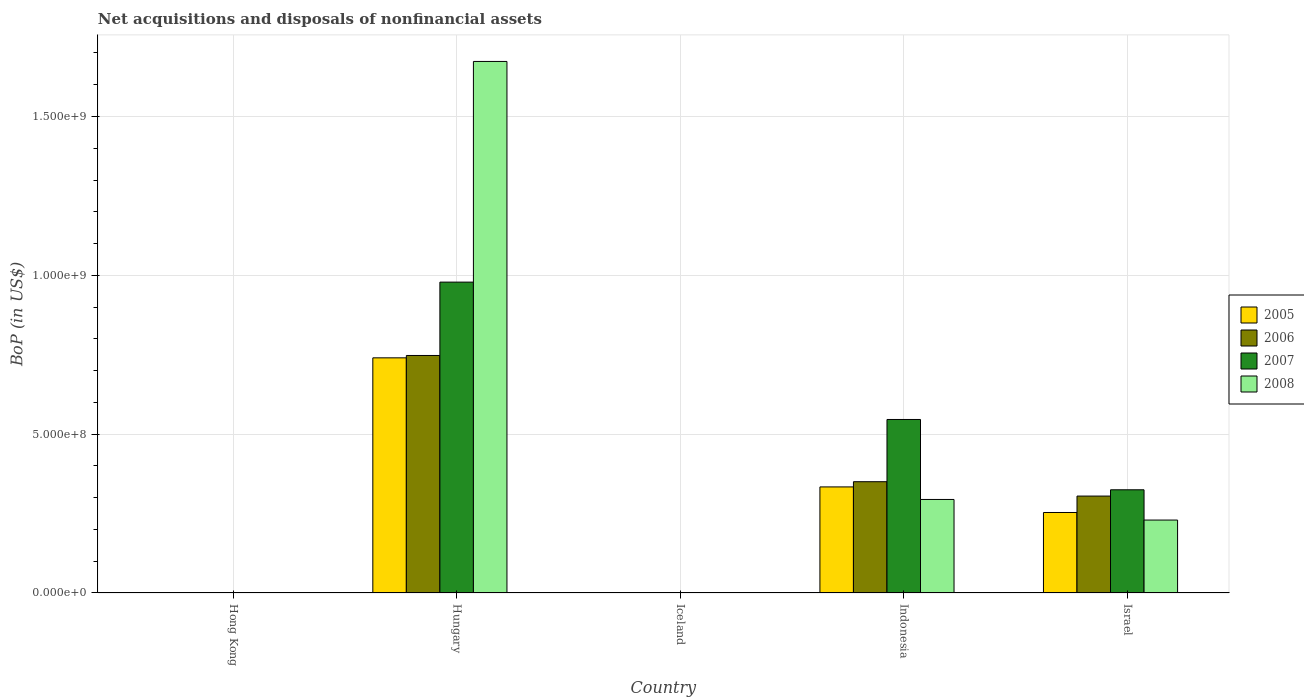How many different coloured bars are there?
Your answer should be very brief. 4. In how many cases, is the number of bars for a given country not equal to the number of legend labels?
Give a very brief answer. 2. What is the Balance of Payments in 2007 in Hong Kong?
Make the answer very short. 0. Across all countries, what is the maximum Balance of Payments in 2007?
Make the answer very short. 9.79e+08. In which country was the Balance of Payments in 2008 maximum?
Provide a succinct answer. Hungary. What is the total Balance of Payments in 2006 in the graph?
Your response must be concise. 1.40e+09. What is the difference between the Balance of Payments in 2006 in Hungary and that in Israel?
Your response must be concise. 4.43e+08. What is the difference between the Balance of Payments in 2007 in Israel and the Balance of Payments in 2006 in Hong Kong?
Provide a short and direct response. 3.25e+08. What is the average Balance of Payments in 2008 per country?
Offer a terse response. 4.39e+08. What is the difference between the Balance of Payments of/in 2008 and Balance of Payments of/in 2005 in Israel?
Make the answer very short. -2.38e+07. In how many countries, is the Balance of Payments in 2008 greater than 1200000000 US$?
Keep it short and to the point. 1. What is the ratio of the Balance of Payments in 2005 in Hungary to that in Israel?
Provide a short and direct response. 2.92. Is the difference between the Balance of Payments in 2008 in Indonesia and Israel greater than the difference between the Balance of Payments in 2005 in Indonesia and Israel?
Give a very brief answer. No. What is the difference between the highest and the second highest Balance of Payments in 2005?
Your answer should be very brief. -4.87e+08. What is the difference between the highest and the lowest Balance of Payments in 2008?
Offer a terse response. 1.67e+09. In how many countries, is the Balance of Payments in 2008 greater than the average Balance of Payments in 2008 taken over all countries?
Give a very brief answer. 1. Is it the case that in every country, the sum of the Balance of Payments in 2006 and Balance of Payments in 2008 is greater than the Balance of Payments in 2005?
Ensure brevity in your answer.  No. Are the values on the major ticks of Y-axis written in scientific E-notation?
Keep it short and to the point. Yes. Does the graph contain any zero values?
Your answer should be compact. Yes. Does the graph contain grids?
Keep it short and to the point. Yes. Where does the legend appear in the graph?
Give a very brief answer. Center right. How are the legend labels stacked?
Ensure brevity in your answer.  Vertical. What is the title of the graph?
Keep it short and to the point. Net acquisitions and disposals of nonfinancial assets. What is the label or title of the Y-axis?
Give a very brief answer. BoP (in US$). What is the BoP (in US$) of 2006 in Hong Kong?
Provide a succinct answer. 0. What is the BoP (in US$) of 2007 in Hong Kong?
Offer a terse response. 0. What is the BoP (in US$) of 2005 in Hungary?
Provide a succinct answer. 7.40e+08. What is the BoP (in US$) of 2006 in Hungary?
Offer a very short reply. 7.48e+08. What is the BoP (in US$) in 2007 in Hungary?
Give a very brief answer. 9.79e+08. What is the BoP (in US$) in 2008 in Hungary?
Your response must be concise. 1.67e+09. What is the BoP (in US$) in 2005 in Iceland?
Offer a very short reply. 0. What is the BoP (in US$) of 2008 in Iceland?
Give a very brief answer. 0. What is the BoP (in US$) in 2005 in Indonesia?
Ensure brevity in your answer.  3.34e+08. What is the BoP (in US$) in 2006 in Indonesia?
Ensure brevity in your answer.  3.50e+08. What is the BoP (in US$) of 2007 in Indonesia?
Make the answer very short. 5.46e+08. What is the BoP (in US$) of 2008 in Indonesia?
Make the answer very short. 2.94e+08. What is the BoP (in US$) in 2005 in Israel?
Offer a terse response. 2.53e+08. What is the BoP (in US$) in 2006 in Israel?
Offer a very short reply. 3.05e+08. What is the BoP (in US$) in 2007 in Israel?
Ensure brevity in your answer.  3.25e+08. What is the BoP (in US$) in 2008 in Israel?
Offer a terse response. 2.30e+08. Across all countries, what is the maximum BoP (in US$) in 2005?
Your answer should be compact. 7.40e+08. Across all countries, what is the maximum BoP (in US$) in 2006?
Ensure brevity in your answer.  7.48e+08. Across all countries, what is the maximum BoP (in US$) of 2007?
Give a very brief answer. 9.79e+08. Across all countries, what is the maximum BoP (in US$) in 2008?
Your answer should be very brief. 1.67e+09. Across all countries, what is the minimum BoP (in US$) in 2005?
Your answer should be very brief. 0. Across all countries, what is the minimum BoP (in US$) in 2006?
Provide a succinct answer. 0. Across all countries, what is the minimum BoP (in US$) of 2007?
Keep it short and to the point. 0. What is the total BoP (in US$) of 2005 in the graph?
Give a very brief answer. 1.33e+09. What is the total BoP (in US$) of 2006 in the graph?
Offer a terse response. 1.40e+09. What is the total BoP (in US$) of 2007 in the graph?
Your answer should be very brief. 1.85e+09. What is the total BoP (in US$) in 2008 in the graph?
Offer a very short reply. 2.20e+09. What is the difference between the BoP (in US$) of 2005 in Hungary and that in Indonesia?
Make the answer very short. 4.06e+08. What is the difference between the BoP (in US$) in 2006 in Hungary and that in Indonesia?
Your response must be concise. 3.97e+08. What is the difference between the BoP (in US$) in 2007 in Hungary and that in Indonesia?
Offer a terse response. 4.32e+08. What is the difference between the BoP (in US$) in 2008 in Hungary and that in Indonesia?
Provide a short and direct response. 1.38e+09. What is the difference between the BoP (in US$) of 2005 in Hungary and that in Israel?
Give a very brief answer. 4.87e+08. What is the difference between the BoP (in US$) of 2006 in Hungary and that in Israel?
Offer a very short reply. 4.43e+08. What is the difference between the BoP (in US$) in 2007 in Hungary and that in Israel?
Offer a terse response. 6.54e+08. What is the difference between the BoP (in US$) of 2008 in Hungary and that in Israel?
Give a very brief answer. 1.44e+09. What is the difference between the BoP (in US$) in 2005 in Indonesia and that in Israel?
Provide a succinct answer. 8.05e+07. What is the difference between the BoP (in US$) of 2006 in Indonesia and that in Israel?
Your answer should be very brief. 4.52e+07. What is the difference between the BoP (in US$) in 2007 in Indonesia and that in Israel?
Offer a terse response. 2.21e+08. What is the difference between the BoP (in US$) of 2008 in Indonesia and that in Israel?
Keep it short and to the point. 6.49e+07. What is the difference between the BoP (in US$) of 2005 in Hungary and the BoP (in US$) of 2006 in Indonesia?
Offer a terse response. 3.90e+08. What is the difference between the BoP (in US$) of 2005 in Hungary and the BoP (in US$) of 2007 in Indonesia?
Offer a terse response. 1.94e+08. What is the difference between the BoP (in US$) of 2005 in Hungary and the BoP (in US$) of 2008 in Indonesia?
Provide a short and direct response. 4.46e+08. What is the difference between the BoP (in US$) in 2006 in Hungary and the BoP (in US$) in 2007 in Indonesia?
Your response must be concise. 2.01e+08. What is the difference between the BoP (in US$) in 2006 in Hungary and the BoP (in US$) in 2008 in Indonesia?
Offer a very short reply. 4.53e+08. What is the difference between the BoP (in US$) in 2007 in Hungary and the BoP (in US$) in 2008 in Indonesia?
Your answer should be compact. 6.84e+08. What is the difference between the BoP (in US$) of 2005 in Hungary and the BoP (in US$) of 2006 in Israel?
Give a very brief answer. 4.35e+08. What is the difference between the BoP (in US$) in 2005 in Hungary and the BoP (in US$) in 2007 in Israel?
Give a very brief answer. 4.15e+08. What is the difference between the BoP (in US$) of 2005 in Hungary and the BoP (in US$) of 2008 in Israel?
Provide a succinct answer. 5.11e+08. What is the difference between the BoP (in US$) in 2006 in Hungary and the BoP (in US$) in 2007 in Israel?
Provide a short and direct response. 4.23e+08. What is the difference between the BoP (in US$) in 2006 in Hungary and the BoP (in US$) in 2008 in Israel?
Offer a terse response. 5.18e+08. What is the difference between the BoP (in US$) of 2007 in Hungary and the BoP (in US$) of 2008 in Israel?
Offer a terse response. 7.49e+08. What is the difference between the BoP (in US$) of 2005 in Indonesia and the BoP (in US$) of 2006 in Israel?
Ensure brevity in your answer.  2.88e+07. What is the difference between the BoP (in US$) of 2005 in Indonesia and the BoP (in US$) of 2007 in Israel?
Offer a terse response. 9.02e+06. What is the difference between the BoP (in US$) of 2005 in Indonesia and the BoP (in US$) of 2008 in Israel?
Offer a very short reply. 1.04e+08. What is the difference between the BoP (in US$) in 2006 in Indonesia and the BoP (in US$) in 2007 in Israel?
Give a very brief answer. 2.54e+07. What is the difference between the BoP (in US$) of 2006 in Indonesia and the BoP (in US$) of 2008 in Israel?
Offer a terse response. 1.21e+08. What is the difference between the BoP (in US$) of 2007 in Indonesia and the BoP (in US$) of 2008 in Israel?
Offer a terse response. 3.17e+08. What is the average BoP (in US$) of 2005 per country?
Keep it short and to the point. 2.66e+08. What is the average BoP (in US$) of 2006 per country?
Your response must be concise. 2.81e+08. What is the average BoP (in US$) in 2007 per country?
Ensure brevity in your answer.  3.70e+08. What is the average BoP (in US$) in 2008 per country?
Ensure brevity in your answer.  4.39e+08. What is the difference between the BoP (in US$) of 2005 and BoP (in US$) of 2006 in Hungary?
Keep it short and to the point. -7.44e+06. What is the difference between the BoP (in US$) in 2005 and BoP (in US$) in 2007 in Hungary?
Your response must be concise. -2.38e+08. What is the difference between the BoP (in US$) of 2005 and BoP (in US$) of 2008 in Hungary?
Ensure brevity in your answer.  -9.33e+08. What is the difference between the BoP (in US$) of 2006 and BoP (in US$) of 2007 in Hungary?
Provide a succinct answer. -2.31e+08. What is the difference between the BoP (in US$) of 2006 and BoP (in US$) of 2008 in Hungary?
Provide a succinct answer. -9.26e+08. What is the difference between the BoP (in US$) in 2007 and BoP (in US$) in 2008 in Hungary?
Offer a very short reply. -6.95e+08. What is the difference between the BoP (in US$) of 2005 and BoP (in US$) of 2006 in Indonesia?
Keep it short and to the point. -1.64e+07. What is the difference between the BoP (in US$) in 2005 and BoP (in US$) in 2007 in Indonesia?
Your response must be concise. -2.12e+08. What is the difference between the BoP (in US$) of 2005 and BoP (in US$) of 2008 in Indonesia?
Give a very brief answer. 3.95e+07. What is the difference between the BoP (in US$) of 2006 and BoP (in US$) of 2007 in Indonesia?
Ensure brevity in your answer.  -1.96e+08. What is the difference between the BoP (in US$) in 2006 and BoP (in US$) in 2008 in Indonesia?
Give a very brief answer. 5.59e+07. What is the difference between the BoP (in US$) in 2007 and BoP (in US$) in 2008 in Indonesia?
Keep it short and to the point. 2.52e+08. What is the difference between the BoP (in US$) of 2005 and BoP (in US$) of 2006 in Israel?
Provide a succinct answer. -5.17e+07. What is the difference between the BoP (in US$) of 2005 and BoP (in US$) of 2007 in Israel?
Offer a very short reply. -7.15e+07. What is the difference between the BoP (in US$) in 2005 and BoP (in US$) in 2008 in Israel?
Provide a succinct answer. 2.38e+07. What is the difference between the BoP (in US$) in 2006 and BoP (in US$) in 2007 in Israel?
Make the answer very short. -1.98e+07. What is the difference between the BoP (in US$) of 2006 and BoP (in US$) of 2008 in Israel?
Make the answer very short. 7.55e+07. What is the difference between the BoP (in US$) of 2007 and BoP (in US$) of 2008 in Israel?
Keep it short and to the point. 9.53e+07. What is the ratio of the BoP (in US$) of 2005 in Hungary to that in Indonesia?
Offer a very short reply. 2.22. What is the ratio of the BoP (in US$) of 2006 in Hungary to that in Indonesia?
Offer a very short reply. 2.13. What is the ratio of the BoP (in US$) of 2007 in Hungary to that in Indonesia?
Give a very brief answer. 1.79. What is the ratio of the BoP (in US$) in 2008 in Hungary to that in Indonesia?
Make the answer very short. 5.68. What is the ratio of the BoP (in US$) in 2005 in Hungary to that in Israel?
Ensure brevity in your answer.  2.92. What is the ratio of the BoP (in US$) in 2006 in Hungary to that in Israel?
Make the answer very short. 2.45. What is the ratio of the BoP (in US$) of 2007 in Hungary to that in Israel?
Your answer should be compact. 3.01. What is the ratio of the BoP (in US$) of 2008 in Hungary to that in Israel?
Ensure brevity in your answer.  7.29. What is the ratio of the BoP (in US$) of 2005 in Indonesia to that in Israel?
Your response must be concise. 1.32. What is the ratio of the BoP (in US$) of 2006 in Indonesia to that in Israel?
Your answer should be very brief. 1.15. What is the ratio of the BoP (in US$) of 2007 in Indonesia to that in Israel?
Your response must be concise. 1.68. What is the ratio of the BoP (in US$) in 2008 in Indonesia to that in Israel?
Provide a succinct answer. 1.28. What is the difference between the highest and the second highest BoP (in US$) of 2005?
Ensure brevity in your answer.  4.06e+08. What is the difference between the highest and the second highest BoP (in US$) of 2006?
Provide a short and direct response. 3.97e+08. What is the difference between the highest and the second highest BoP (in US$) in 2007?
Ensure brevity in your answer.  4.32e+08. What is the difference between the highest and the second highest BoP (in US$) in 2008?
Your answer should be very brief. 1.38e+09. What is the difference between the highest and the lowest BoP (in US$) of 2005?
Offer a terse response. 7.40e+08. What is the difference between the highest and the lowest BoP (in US$) in 2006?
Give a very brief answer. 7.48e+08. What is the difference between the highest and the lowest BoP (in US$) of 2007?
Your response must be concise. 9.79e+08. What is the difference between the highest and the lowest BoP (in US$) in 2008?
Make the answer very short. 1.67e+09. 